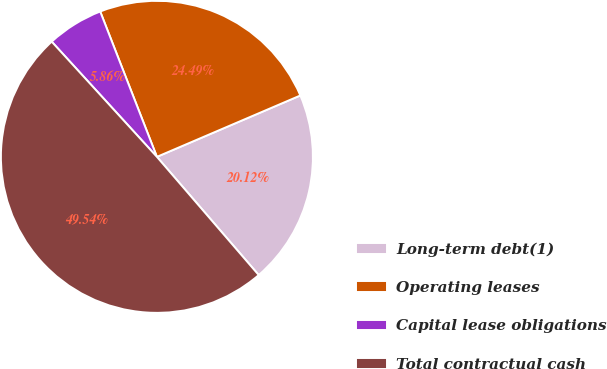Convert chart to OTSL. <chart><loc_0><loc_0><loc_500><loc_500><pie_chart><fcel>Long-term debt(1)<fcel>Operating leases<fcel>Capital lease obligations<fcel>Total contractual cash<nl><fcel>20.12%<fcel>24.49%<fcel>5.86%<fcel>49.54%<nl></chart> 